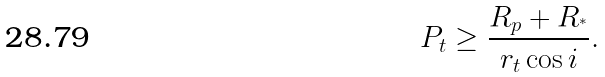<formula> <loc_0><loc_0><loc_500><loc_500>P _ { t } \geq \frac { R _ { p } + R _ { ^ { * } } } { r _ { t } \cos i } .</formula> 